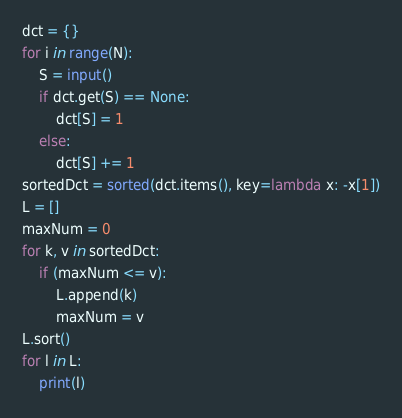Convert code to text. <code><loc_0><loc_0><loc_500><loc_500><_Python_>dct = {}
for i in range(N):
    S = input()
    if dct.get(S) == None:
        dct[S] = 1
    else:
        dct[S] += 1
sortedDct = sorted(dct.items(), key=lambda x: -x[1])
L = []
maxNum = 0
for k, v in sortedDct:
    if (maxNum <= v):
        L.append(k)
        maxNum = v
L.sort()
for l in L:
    print(l)</code> 